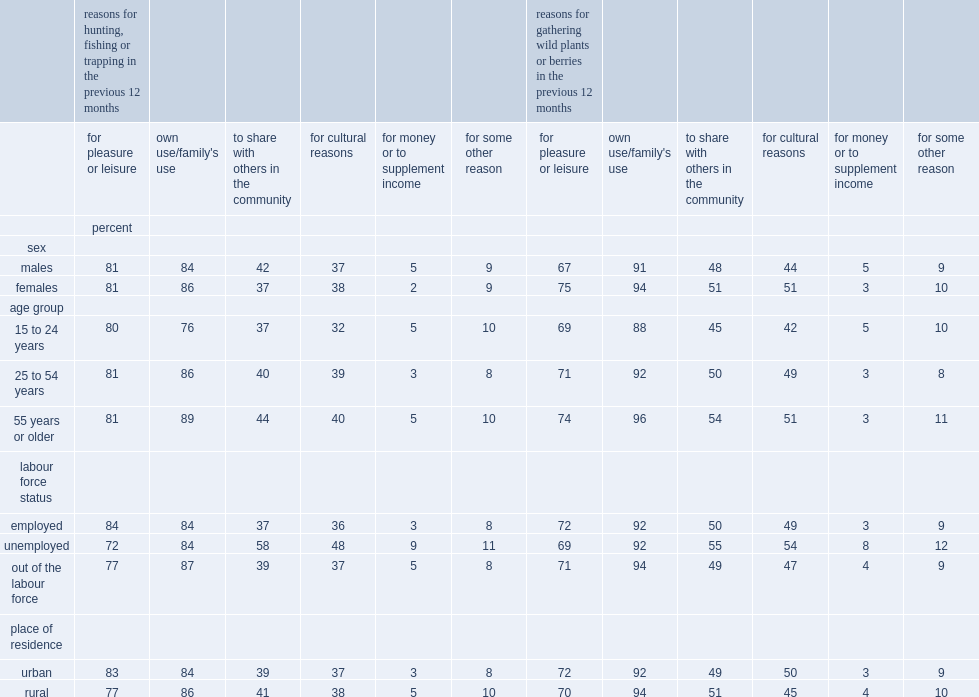When it came to hunting, fishing or trapping for own use or own family's use, what was the proportion among youth and young adults? 76. When it came to hunting, fishing or trapping for own use or own family's use, what was the proportion among working-age adults? 86. What was the rate of hunting, fishing or trapping to share with others in the community among unemployed first nations people? 58. What was the rate of hunting, fishing or trapping to share with others in the community among unemployed first nations people out of the labour force? 39. Was hunting, fishing or trapping to share with others in the community more likely among males or females? Males. Which group was less likely to hunt, fish or trap for cultural reasons, youth and young adults or core working-age adults? 15 to 24 years. Which group was less likely to hunt, fish or trap for cultural reasons, youth and young adults or older adults? 15 to 24 years. Which gourp was more likely to participate in hunting, fishing or trapping for cultural reasons, those who were employed or unemployed? Unemployed. Which gourp was more likely to participate in hunting, fishing or trapping for cultural reasons, those who were out-of-the-labour-force or unemployed? Unemployed. How many times were males as likely as females to engage in hunting, fishing or trapping activities for money or to supplement income? 2.5. How many times were unemployed individuals as likely as employed individuals to hunt, fish or trap for money or to supplement income? 3. Which group was more likely to report hunting, fishing or trapping for money or to supplement income, those living in rural areas or urban areas? Rural. 